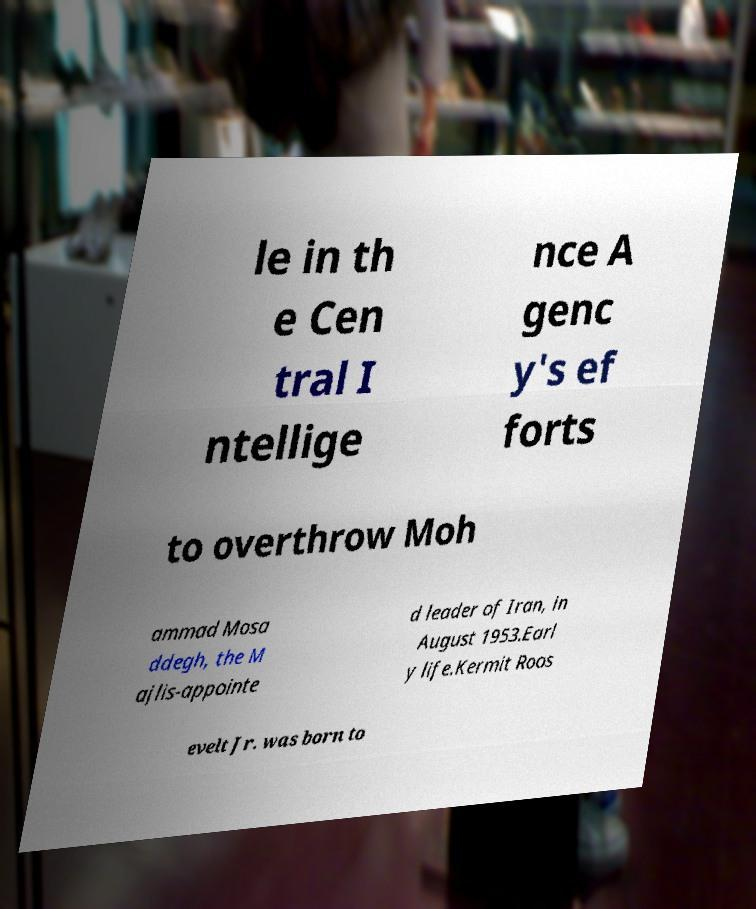Can you read and provide the text displayed in the image?This photo seems to have some interesting text. Can you extract and type it out for me? le in th e Cen tral I ntellige nce A genc y's ef forts to overthrow Moh ammad Mosa ddegh, the M ajlis-appointe d leader of Iran, in August 1953.Earl y life.Kermit Roos evelt Jr. was born to 